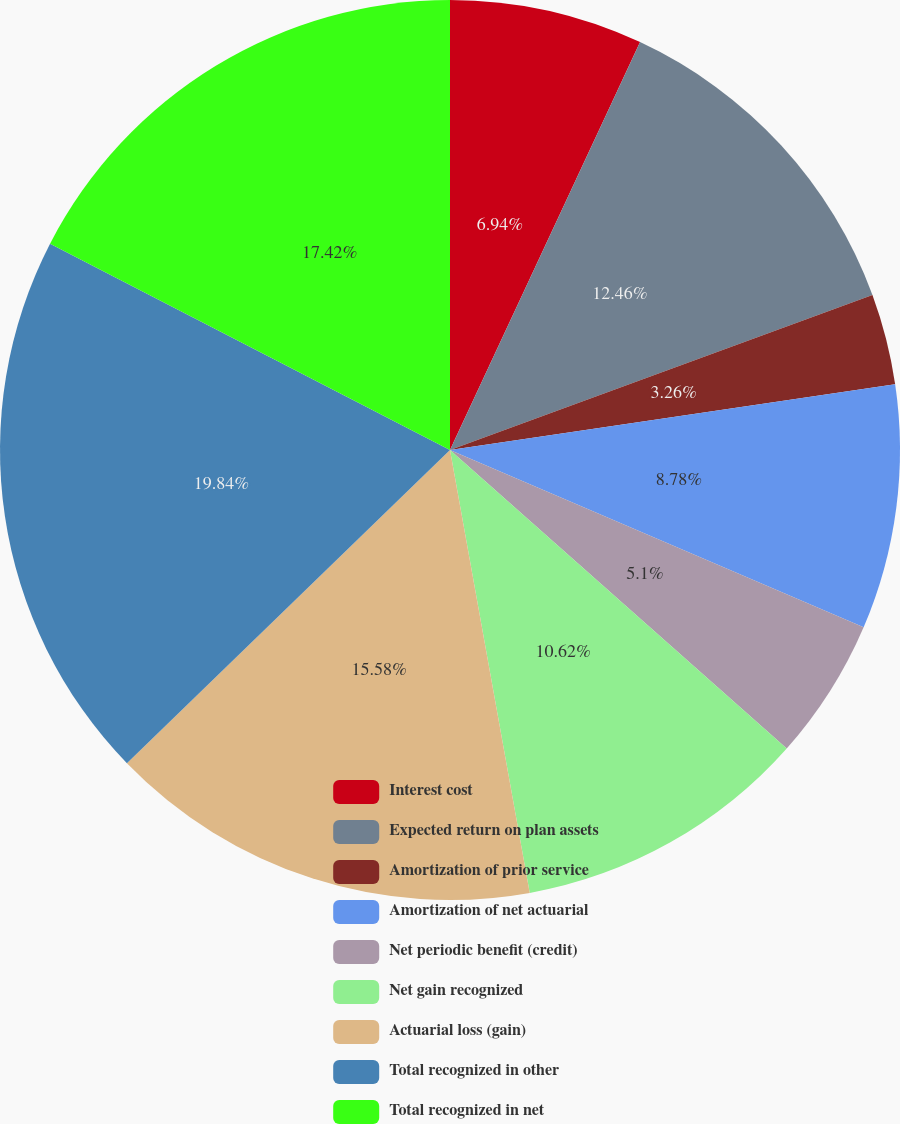Convert chart. <chart><loc_0><loc_0><loc_500><loc_500><pie_chart><fcel>Interest cost<fcel>Expected return on plan assets<fcel>Amortization of prior service<fcel>Amortization of net actuarial<fcel>Net periodic benefit (credit)<fcel>Net gain recognized<fcel>Actuarial loss (gain)<fcel>Total recognized in other<fcel>Total recognized in net<nl><fcel>6.94%<fcel>12.46%<fcel>3.26%<fcel>8.78%<fcel>5.1%<fcel>10.62%<fcel>15.58%<fcel>19.83%<fcel>17.42%<nl></chart> 